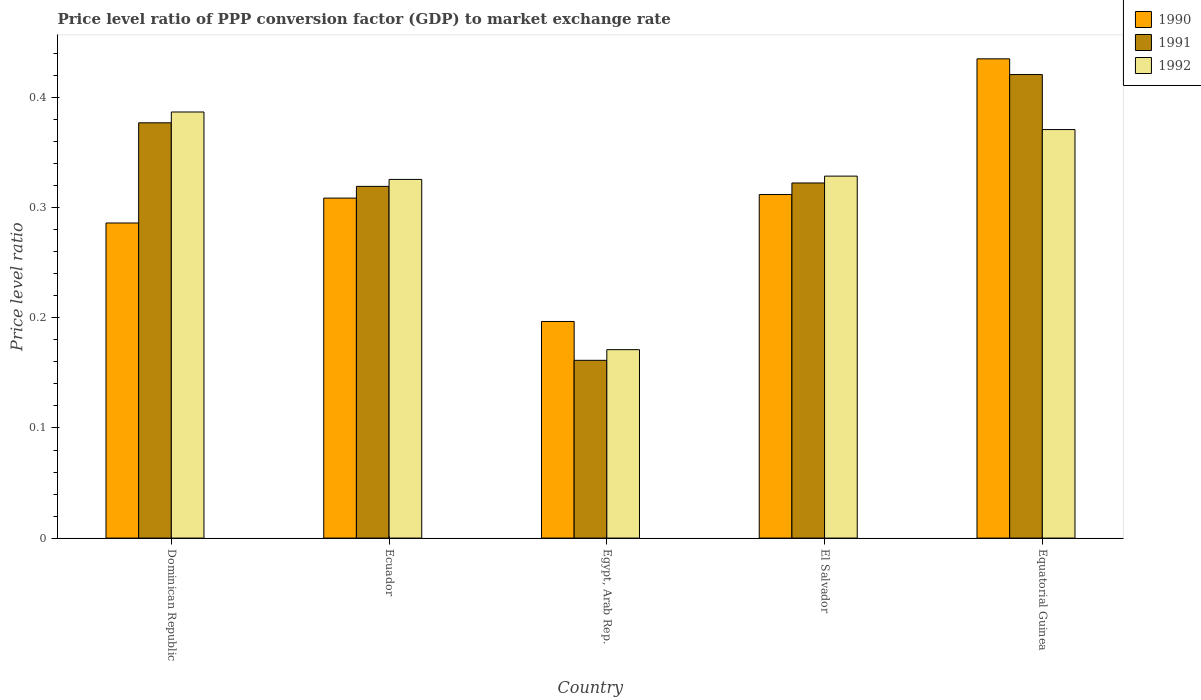Are the number of bars per tick equal to the number of legend labels?
Ensure brevity in your answer.  Yes. How many bars are there on the 2nd tick from the right?
Your answer should be compact. 3. What is the label of the 4th group of bars from the left?
Provide a succinct answer. El Salvador. What is the price level ratio in 1991 in Dominican Republic?
Provide a succinct answer. 0.38. Across all countries, what is the maximum price level ratio in 1990?
Your answer should be compact. 0.44. Across all countries, what is the minimum price level ratio in 1992?
Your answer should be compact. 0.17. In which country was the price level ratio in 1990 maximum?
Offer a terse response. Equatorial Guinea. In which country was the price level ratio in 1991 minimum?
Your answer should be compact. Egypt, Arab Rep. What is the total price level ratio in 1990 in the graph?
Provide a succinct answer. 1.54. What is the difference between the price level ratio in 1990 in Dominican Republic and that in Equatorial Guinea?
Provide a succinct answer. -0.15. What is the difference between the price level ratio in 1992 in Equatorial Guinea and the price level ratio in 1990 in Dominican Republic?
Keep it short and to the point. 0.08. What is the average price level ratio in 1992 per country?
Keep it short and to the point. 0.32. What is the difference between the price level ratio of/in 1990 and price level ratio of/in 1992 in Ecuador?
Provide a succinct answer. -0.02. What is the ratio of the price level ratio in 1992 in Dominican Republic to that in Egypt, Arab Rep.?
Your answer should be very brief. 2.26. Is the price level ratio in 1990 in Dominican Republic less than that in Equatorial Guinea?
Provide a short and direct response. Yes. Is the difference between the price level ratio in 1990 in Dominican Republic and El Salvador greater than the difference between the price level ratio in 1992 in Dominican Republic and El Salvador?
Your answer should be very brief. No. What is the difference between the highest and the second highest price level ratio in 1992?
Give a very brief answer. 0.02. What is the difference between the highest and the lowest price level ratio in 1991?
Your answer should be very brief. 0.26. In how many countries, is the price level ratio in 1992 greater than the average price level ratio in 1992 taken over all countries?
Give a very brief answer. 4. What does the 1st bar from the left in El Salvador represents?
Ensure brevity in your answer.  1990. What does the 3rd bar from the right in El Salvador represents?
Give a very brief answer. 1990. Are all the bars in the graph horizontal?
Keep it short and to the point. No. How many countries are there in the graph?
Your answer should be very brief. 5. What is the difference between two consecutive major ticks on the Y-axis?
Your response must be concise. 0.1. Are the values on the major ticks of Y-axis written in scientific E-notation?
Keep it short and to the point. No. Does the graph contain any zero values?
Ensure brevity in your answer.  No. Does the graph contain grids?
Give a very brief answer. No. Where does the legend appear in the graph?
Provide a succinct answer. Top right. How are the legend labels stacked?
Your response must be concise. Vertical. What is the title of the graph?
Offer a terse response. Price level ratio of PPP conversion factor (GDP) to market exchange rate. Does "1973" appear as one of the legend labels in the graph?
Offer a very short reply. No. What is the label or title of the X-axis?
Offer a very short reply. Country. What is the label or title of the Y-axis?
Make the answer very short. Price level ratio. What is the Price level ratio of 1990 in Dominican Republic?
Your answer should be compact. 0.29. What is the Price level ratio of 1991 in Dominican Republic?
Your response must be concise. 0.38. What is the Price level ratio of 1992 in Dominican Republic?
Your answer should be very brief. 0.39. What is the Price level ratio of 1990 in Ecuador?
Make the answer very short. 0.31. What is the Price level ratio in 1991 in Ecuador?
Provide a short and direct response. 0.32. What is the Price level ratio in 1992 in Ecuador?
Your response must be concise. 0.33. What is the Price level ratio of 1990 in Egypt, Arab Rep.?
Offer a very short reply. 0.2. What is the Price level ratio in 1991 in Egypt, Arab Rep.?
Ensure brevity in your answer.  0.16. What is the Price level ratio in 1992 in Egypt, Arab Rep.?
Make the answer very short. 0.17. What is the Price level ratio in 1990 in El Salvador?
Make the answer very short. 0.31. What is the Price level ratio of 1991 in El Salvador?
Provide a succinct answer. 0.32. What is the Price level ratio in 1992 in El Salvador?
Ensure brevity in your answer.  0.33. What is the Price level ratio of 1990 in Equatorial Guinea?
Provide a short and direct response. 0.44. What is the Price level ratio of 1991 in Equatorial Guinea?
Your answer should be compact. 0.42. What is the Price level ratio in 1992 in Equatorial Guinea?
Keep it short and to the point. 0.37. Across all countries, what is the maximum Price level ratio in 1990?
Your response must be concise. 0.44. Across all countries, what is the maximum Price level ratio of 1991?
Ensure brevity in your answer.  0.42. Across all countries, what is the maximum Price level ratio in 1992?
Your answer should be very brief. 0.39. Across all countries, what is the minimum Price level ratio in 1990?
Ensure brevity in your answer.  0.2. Across all countries, what is the minimum Price level ratio in 1991?
Provide a short and direct response. 0.16. Across all countries, what is the minimum Price level ratio of 1992?
Give a very brief answer. 0.17. What is the total Price level ratio in 1990 in the graph?
Your answer should be very brief. 1.54. What is the total Price level ratio in 1991 in the graph?
Give a very brief answer. 1.6. What is the total Price level ratio in 1992 in the graph?
Offer a very short reply. 1.58. What is the difference between the Price level ratio in 1990 in Dominican Republic and that in Ecuador?
Keep it short and to the point. -0.02. What is the difference between the Price level ratio of 1991 in Dominican Republic and that in Ecuador?
Your answer should be compact. 0.06. What is the difference between the Price level ratio of 1992 in Dominican Republic and that in Ecuador?
Your response must be concise. 0.06. What is the difference between the Price level ratio of 1990 in Dominican Republic and that in Egypt, Arab Rep.?
Make the answer very short. 0.09. What is the difference between the Price level ratio in 1991 in Dominican Republic and that in Egypt, Arab Rep.?
Your answer should be very brief. 0.22. What is the difference between the Price level ratio of 1992 in Dominican Republic and that in Egypt, Arab Rep.?
Ensure brevity in your answer.  0.22. What is the difference between the Price level ratio in 1990 in Dominican Republic and that in El Salvador?
Make the answer very short. -0.03. What is the difference between the Price level ratio in 1991 in Dominican Republic and that in El Salvador?
Keep it short and to the point. 0.05. What is the difference between the Price level ratio of 1992 in Dominican Republic and that in El Salvador?
Give a very brief answer. 0.06. What is the difference between the Price level ratio in 1990 in Dominican Republic and that in Equatorial Guinea?
Offer a very short reply. -0.15. What is the difference between the Price level ratio of 1991 in Dominican Republic and that in Equatorial Guinea?
Provide a short and direct response. -0.04. What is the difference between the Price level ratio of 1992 in Dominican Republic and that in Equatorial Guinea?
Your answer should be very brief. 0.02. What is the difference between the Price level ratio of 1990 in Ecuador and that in Egypt, Arab Rep.?
Offer a very short reply. 0.11. What is the difference between the Price level ratio of 1991 in Ecuador and that in Egypt, Arab Rep.?
Your response must be concise. 0.16. What is the difference between the Price level ratio in 1992 in Ecuador and that in Egypt, Arab Rep.?
Your answer should be very brief. 0.15. What is the difference between the Price level ratio of 1990 in Ecuador and that in El Salvador?
Provide a short and direct response. -0. What is the difference between the Price level ratio of 1991 in Ecuador and that in El Salvador?
Give a very brief answer. -0. What is the difference between the Price level ratio of 1992 in Ecuador and that in El Salvador?
Offer a terse response. -0. What is the difference between the Price level ratio of 1990 in Ecuador and that in Equatorial Guinea?
Offer a terse response. -0.13. What is the difference between the Price level ratio of 1991 in Ecuador and that in Equatorial Guinea?
Provide a short and direct response. -0.1. What is the difference between the Price level ratio in 1992 in Ecuador and that in Equatorial Guinea?
Offer a very short reply. -0.05. What is the difference between the Price level ratio in 1990 in Egypt, Arab Rep. and that in El Salvador?
Your response must be concise. -0.12. What is the difference between the Price level ratio of 1991 in Egypt, Arab Rep. and that in El Salvador?
Provide a succinct answer. -0.16. What is the difference between the Price level ratio in 1992 in Egypt, Arab Rep. and that in El Salvador?
Make the answer very short. -0.16. What is the difference between the Price level ratio in 1990 in Egypt, Arab Rep. and that in Equatorial Guinea?
Keep it short and to the point. -0.24. What is the difference between the Price level ratio of 1991 in Egypt, Arab Rep. and that in Equatorial Guinea?
Offer a very short reply. -0.26. What is the difference between the Price level ratio of 1992 in Egypt, Arab Rep. and that in Equatorial Guinea?
Keep it short and to the point. -0.2. What is the difference between the Price level ratio in 1990 in El Salvador and that in Equatorial Guinea?
Give a very brief answer. -0.12. What is the difference between the Price level ratio of 1991 in El Salvador and that in Equatorial Guinea?
Your answer should be very brief. -0.1. What is the difference between the Price level ratio of 1992 in El Salvador and that in Equatorial Guinea?
Keep it short and to the point. -0.04. What is the difference between the Price level ratio in 1990 in Dominican Republic and the Price level ratio in 1991 in Ecuador?
Keep it short and to the point. -0.03. What is the difference between the Price level ratio in 1990 in Dominican Republic and the Price level ratio in 1992 in Ecuador?
Your response must be concise. -0.04. What is the difference between the Price level ratio in 1991 in Dominican Republic and the Price level ratio in 1992 in Ecuador?
Your answer should be very brief. 0.05. What is the difference between the Price level ratio in 1990 in Dominican Republic and the Price level ratio in 1991 in Egypt, Arab Rep.?
Ensure brevity in your answer.  0.12. What is the difference between the Price level ratio of 1990 in Dominican Republic and the Price level ratio of 1992 in Egypt, Arab Rep.?
Make the answer very short. 0.12. What is the difference between the Price level ratio of 1991 in Dominican Republic and the Price level ratio of 1992 in Egypt, Arab Rep.?
Provide a short and direct response. 0.21. What is the difference between the Price level ratio in 1990 in Dominican Republic and the Price level ratio in 1991 in El Salvador?
Ensure brevity in your answer.  -0.04. What is the difference between the Price level ratio of 1990 in Dominican Republic and the Price level ratio of 1992 in El Salvador?
Ensure brevity in your answer.  -0.04. What is the difference between the Price level ratio in 1991 in Dominican Republic and the Price level ratio in 1992 in El Salvador?
Your answer should be very brief. 0.05. What is the difference between the Price level ratio of 1990 in Dominican Republic and the Price level ratio of 1991 in Equatorial Guinea?
Offer a terse response. -0.13. What is the difference between the Price level ratio of 1990 in Dominican Republic and the Price level ratio of 1992 in Equatorial Guinea?
Keep it short and to the point. -0.08. What is the difference between the Price level ratio of 1991 in Dominican Republic and the Price level ratio of 1992 in Equatorial Guinea?
Provide a short and direct response. 0.01. What is the difference between the Price level ratio of 1990 in Ecuador and the Price level ratio of 1991 in Egypt, Arab Rep.?
Make the answer very short. 0.15. What is the difference between the Price level ratio of 1990 in Ecuador and the Price level ratio of 1992 in Egypt, Arab Rep.?
Keep it short and to the point. 0.14. What is the difference between the Price level ratio in 1991 in Ecuador and the Price level ratio in 1992 in Egypt, Arab Rep.?
Ensure brevity in your answer.  0.15. What is the difference between the Price level ratio in 1990 in Ecuador and the Price level ratio in 1991 in El Salvador?
Give a very brief answer. -0.01. What is the difference between the Price level ratio of 1990 in Ecuador and the Price level ratio of 1992 in El Salvador?
Make the answer very short. -0.02. What is the difference between the Price level ratio of 1991 in Ecuador and the Price level ratio of 1992 in El Salvador?
Provide a succinct answer. -0.01. What is the difference between the Price level ratio of 1990 in Ecuador and the Price level ratio of 1991 in Equatorial Guinea?
Offer a very short reply. -0.11. What is the difference between the Price level ratio of 1990 in Ecuador and the Price level ratio of 1992 in Equatorial Guinea?
Your answer should be very brief. -0.06. What is the difference between the Price level ratio of 1991 in Ecuador and the Price level ratio of 1992 in Equatorial Guinea?
Provide a succinct answer. -0.05. What is the difference between the Price level ratio in 1990 in Egypt, Arab Rep. and the Price level ratio in 1991 in El Salvador?
Your response must be concise. -0.13. What is the difference between the Price level ratio of 1990 in Egypt, Arab Rep. and the Price level ratio of 1992 in El Salvador?
Your answer should be very brief. -0.13. What is the difference between the Price level ratio in 1991 in Egypt, Arab Rep. and the Price level ratio in 1992 in El Salvador?
Provide a short and direct response. -0.17. What is the difference between the Price level ratio in 1990 in Egypt, Arab Rep. and the Price level ratio in 1991 in Equatorial Guinea?
Offer a terse response. -0.22. What is the difference between the Price level ratio of 1990 in Egypt, Arab Rep. and the Price level ratio of 1992 in Equatorial Guinea?
Offer a terse response. -0.17. What is the difference between the Price level ratio in 1991 in Egypt, Arab Rep. and the Price level ratio in 1992 in Equatorial Guinea?
Your response must be concise. -0.21. What is the difference between the Price level ratio in 1990 in El Salvador and the Price level ratio in 1991 in Equatorial Guinea?
Provide a short and direct response. -0.11. What is the difference between the Price level ratio in 1990 in El Salvador and the Price level ratio in 1992 in Equatorial Guinea?
Your answer should be very brief. -0.06. What is the difference between the Price level ratio of 1991 in El Salvador and the Price level ratio of 1992 in Equatorial Guinea?
Make the answer very short. -0.05. What is the average Price level ratio of 1990 per country?
Your response must be concise. 0.31. What is the average Price level ratio in 1991 per country?
Ensure brevity in your answer.  0.32. What is the average Price level ratio in 1992 per country?
Keep it short and to the point. 0.32. What is the difference between the Price level ratio of 1990 and Price level ratio of 1991 in Dominican Republic?
Make the answer very short. -0.09. What is the difference between the Price level ratio in 1990 and Price level ratio in 1992 in Dominican Republic?
Offer a terse response. -0.1. What is the difference between the Price level ratio of 1991 and Price level ratio of 1992 in Dominican Republic?
Your answer should be very brief. -0.01. What is the difference between the Price level ratio in 1990 and Price level ratio in 1991 in Ecuador?
Your answer should be very brief. -0.01. What is the difference between the Price level ratio of 1990 and Price level ratio of 1992 in Ecuador?
Your response must be concise. -0.02. What is the difference between the Price level ratio in 1991 and Price level ratio in 1992 in Ecuador?
Offer a very short reply. -0.01. What is the difference between the Price level ratio of 1990 and Price level ratio of 1991 in Egypt, Arab Rep.?
Your response must be concise. 0.04. What is the difference between the Price level ratio of 1990 and Price level ratio of 1992 in Egypt, Arab Rep.?
Your response must be concise. 0.03. What is the difference between the Price level ratio of 1991 and Price level ratio of 1992 in Egypt, Arab Rep.?
Give a very brief answer. -0.01. What is the difference between the Price level ratio of 1990 and Price level ratio of 1991 in El Salvador?
Ensure brevity in your answer.  -0.01. What is the difference between the Price level ratio in 1990 and Price level ratio in 1992 in El Salvador?
Provide a succinct answer. -0.02. What is the difference between the Price level ratio in 1991 and Price level ratio in 1992 in El Salvador?
Provide a succinct answer. -0.01. What is the difference between the Price level ratio in 1990 and Price level ratio in 1991 in Equatorial Guinea?
Offer a very short reply. 0.01. What is the difference between the Price level ratio in 1990 and Price level ratio in 1992 in Equatorial Guinea?
Give a very brief answer. 0.06. What is the difference between the Price level ratio of 1991 and Price level ratio of 1992 in Equatorial Guinea?
Give a very brief answer. 0.05. What is the ratio of the Price level ratio in 1990 in Dominican Republic to that in Ecuador?
Offer a very short reply. 0.93. What is the ratio of the Price level ratio in 1991 in Dominican Republic to that in Ecuador?
Provide a succinct answer. 1.18. What is the ratio of the Price level ratio of 1992 in Dominican Republic to that in Ecuador?
Provide a succinct answer. 1.19. What is the ratio of the Price level ratio in 1990 in Dominican Republic to that in Egypt, Arab Rep.?
Provide a short and direct response. 1.45. What is the ratio of the Price level ratio in 1991 in Dominican Republic to that in Egypt, Arab Rep.?
Ensure brevity in your answer.  2.34. What is the ratio of the Price level ratio in 1992 in Dominican Republic to that in Egypt, Arab Rep.?
Provide a succinct answer. 2.26. What is the ratio of the Price level ratio in 1990 in Dominican Republic to that in El Salvador?
Ensure brevity in your answer.  0.92. What is the ratio of the Price level ratio in 1991 in Dominican Republic to that in El Salvador?
Provide a succinct answer. 1.17. What is the ratio of the Price level ratio of 1992 in Dominican Republic to that in El Salvador?
Your response must be concise. 1.18. What is the ratio of the Price level ratio in 1990 in Dominican Republic to that in Equatorial Guinea?
Ensure brevity in your answer.  0.66. What is the ratio of the Price level ratio of 1991 in Dominican Republic to that in Equatorial Guinea?
Keep it short and to the point. 0.9. What is the ratio of the Price level ratio in 1992 in Dominican Republic to that in Equatorial Guinea?
Make the answer very short. 1.04. What is the ratio of the Price level ratio of 1990 in Ecuador to that in Egypt, Arab Rep.?
Your response must be concise. 1.57. What is the ratio of the Price level ratio in 1991 in Ecuador to that in Egypt, Arab Rep.?
Provide a succinct answer. 1.98. What is the ratio of the Price level ratio of 1992 in Ecuador to that in Egypt, Arab Rep.?
Make the answer very short. 1.9. What is the ratio of the Price level ratio of 1990 in Ecuador to that in El Salvador?
Your answer should be very brief. 0.99. What is the ratio of the Price level ratio of 1992 in Ecuador to that in El Salvador?
Provide a short and direct response. 0.99. What is the ratio of the Price level ratio in 1990 in Ecuador to that in Equatorial Guinea?
Give a very brief answer. 0.71. What is the ratio of the Price level ratio of 1991 in Ecuador to that in Equatorial Guinea?
Your answer should be very brief. 0.76. What is the ratio of the Price level ratio of 1992 in Ecuador to that in Equatorial Guinea?
Your answer should be compact. 0.88. What is the ratio of the Price level ratio in 1990 in Egypt, Arab Rep. to that in El Salvador?
Provide a succinct answer. 0.63. What is the ratio of the Price level ratio of 1991 in Egypt, Arab Rep. to that in El Salvador?
Make the answer very short. 0.5. What is the ratio of the Price level ratio in 1992 in Egypt, Arab Rep. to that in El Salvador?
Offer a terse response. 0.52. What is the ratio of the Price level ratio of 1990 in Egypt, Arab Rep. to that in Equatorial Guinea?
Keep it short and to the point. 0.45. What is the ratio of the Price level ratio in 1991 in Egypt, Arab Rep. to that in Equatorial Guinea?
Offer a terse response. 0.38. What is the ratio of the Price level ratio in 1992 in Egypt, Arab Rep. to that in Equatorial Guinea?
Keep it short and to the point. 0.46. What is the ratio of the Price level ratio of 1990 in El Salvador to that in Equatorial Guinea?
Your response must be concise. 0.72. What is the ratio of the Price level ratio in 1991 in El Salvador to that in Equatorial Guinea?
Offer a very short reply. 0.77. What is the ratio of the Price level ratio of 1992 in El Salvador to that in Equatorial Guinea?
Give a very brief answer. 0.89. What is the difference between the highest and the second highest Price level ratio of 1990?
Make the answer very short. 0.12. What is the difference between the highest and the second highest Price level ratio of 1991?
Offer a very short reply. 0.04. What is the difference between the highest and the second highest Price level ratio of 1992?
Your answer should be compact. 0.02. What is the difference between the highest and the lowest Price level ratio of 1990?
Give a very brief answer. 0.24. What is the difference between the highest and the lowest Price level ratio of 1991?
Your response must be concise. 0.26. What is the difference between the highest and the lowest Price level ratio of 1992?
Your answer should be compact. 0.22. 